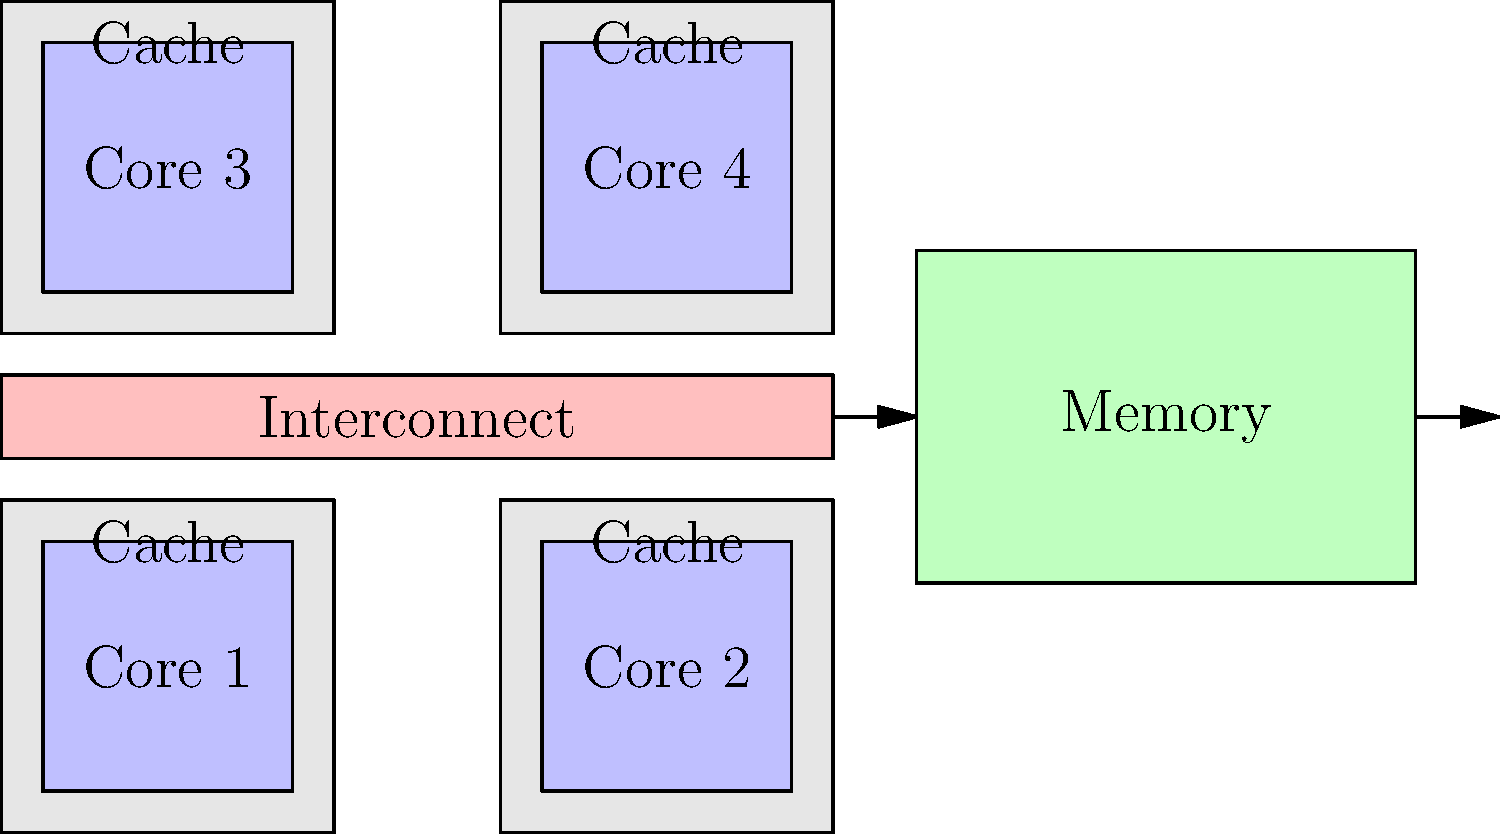In the multi-core system shown above, which cache coherence protocol would be most efficient for maintaining consistency while minimizing unnecessary cache invalidations? Explain your reasoning, and don't forget to throw in a pun-chy explanation! Let's break this down step-by-step:

1. Observe the system architecture:
   - We have a quad-core system, each with its own private cache.
   - The cores are connected via an interconnect to shared memory.

2. Consider the requirements:
   - We need to maintain cache consistency across all cores.
   - We want to minimize unnecessary cache invalidations.

3. Evaluate common cache coherence protocols:
   - MSI (Modified, Shared, Invalid): Basic protocol, but may lead to unnecessary invalidations.
   - MESI (Modified, Exclusive, Shared, Invalid): Adds an Exclusive state, reducing invalidations.
   - MOESI (Modified, Owned, Exclusive, Shared, Invalid): Further optimizes by allowing direct cache-to-cache transfers.

4. Analyze the best fit:
   - MOESI would be the most efficient for this system because:
     a) It allows for direct cache-to-cache transfers, reducing memory accesses.
     b) The Owned state helps minimize unnecessary invalidations.
     c) It works well in multi-core systems with shared memory, like the one shown.

5. Consider the pun-tential:
   - MOESI is the way to go, as it helps the cores stay in sync without getting too "in-valid-ated"!
Answer: MOESI (Modified, Owned, Exclusive, Shared, Invalid) protocol 